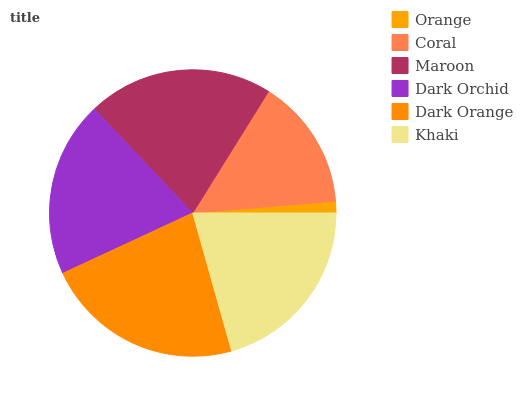Is Orange the minimum?
Answer yes or no. Yes. Is Dark Orange the maximum?
Answer yes or no. Yes. Is Coral the minimum?
Answer yes or no. No. Is Coral the maximum?
Answer yes or no. No. Is Coral greater than Orange?
Answer yes or no. Yes. Is Orange less than Coral?
Answer yes or no. Yes. Is Orange greater than Coral?
Answer yes or no. No. Is Coral less than Orange?
Answer yes or no. No. Is Khaki the high median?
Answer yes or no. Yes. Is Dark Orchid the low median?
Answer yes or no. Yes. Is Dark Orange the high median?
Answer yes or no. No. Is Orange the low median?
Answer yes or no. No. 